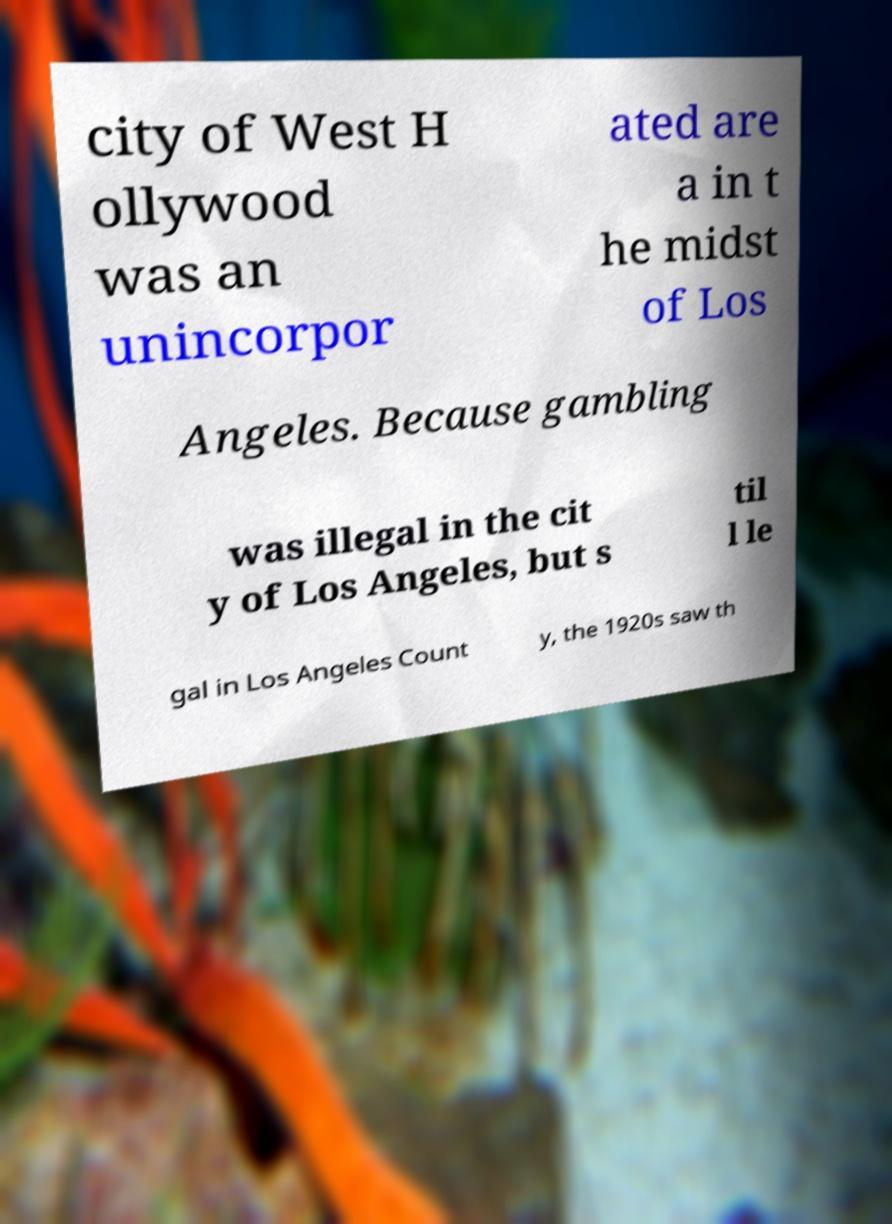For documentation purposes, I need the text within this image transcribed. Could you provide that? city of West H ollywood was an unincorpor ated are a in t he midst of Los Angeles. Because gambling was illegal in the cit y of Los Angeles, but s til l le gal in Los Angeles Count y, the 1920s saw th 